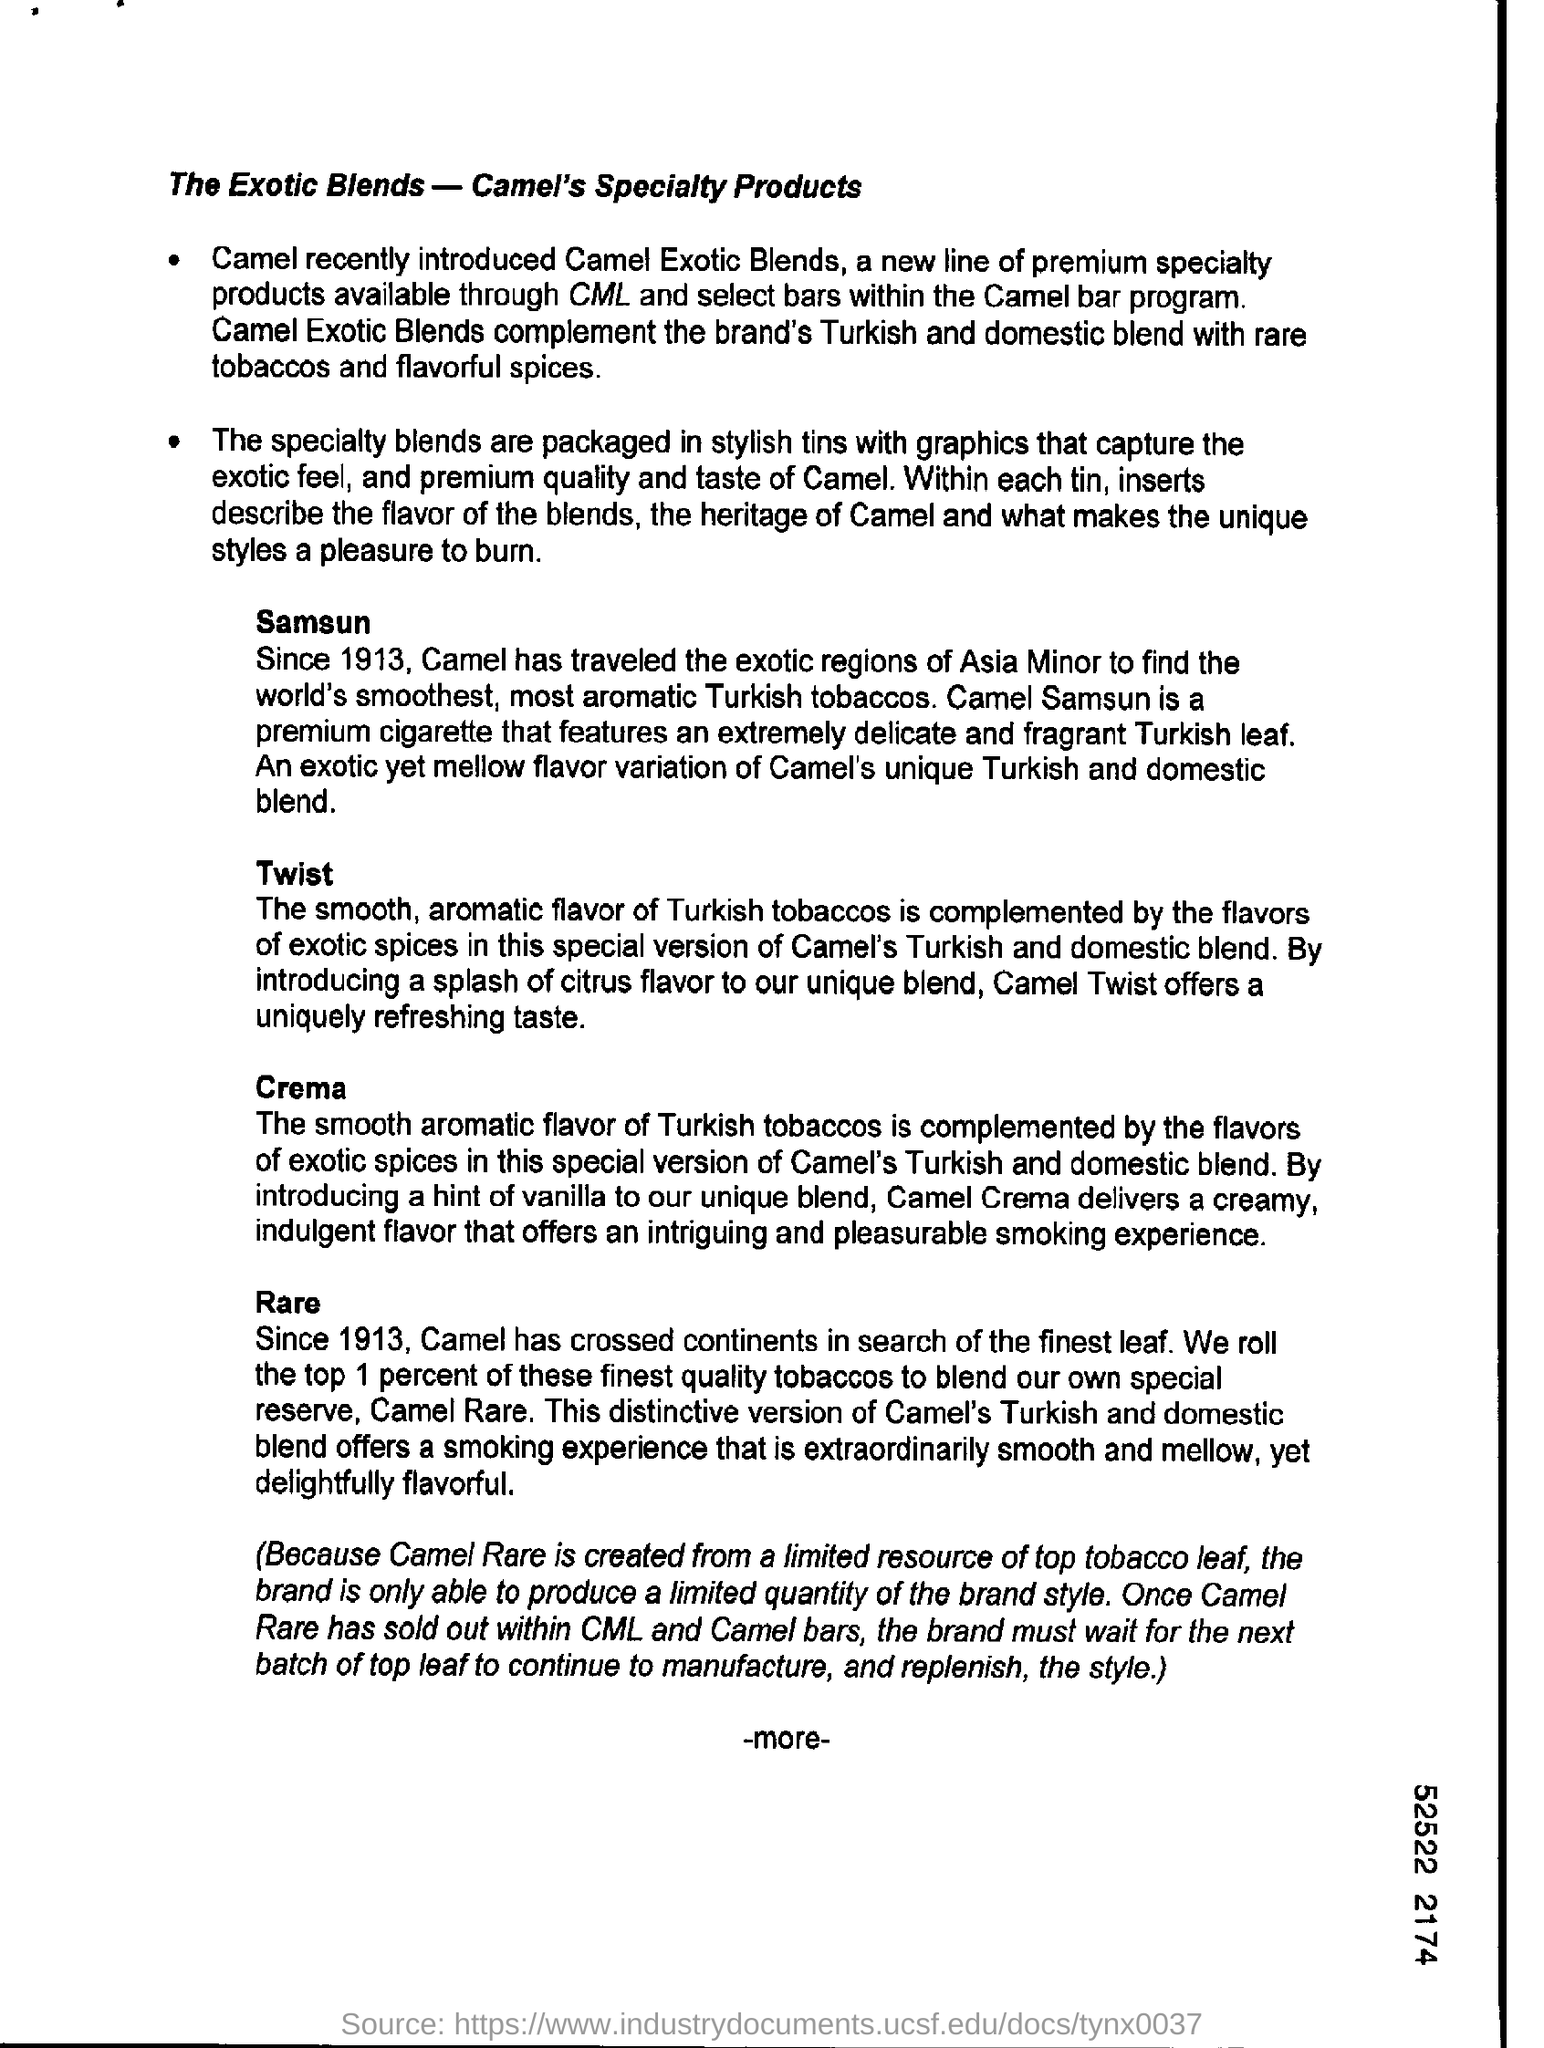Which brands did camel exotic blends compliment?
Provide a short and direct response. The brand's turkish and domestic blend with rare tobaccos and flavorful spices. What does camel crema deliver?
Give a very brief answer. A creamy indulgent flavor that offers an intriguing and pleasurable smoking experience. How are speciality blends packed?
Your response must be concise. In stylish tins with graphics. 